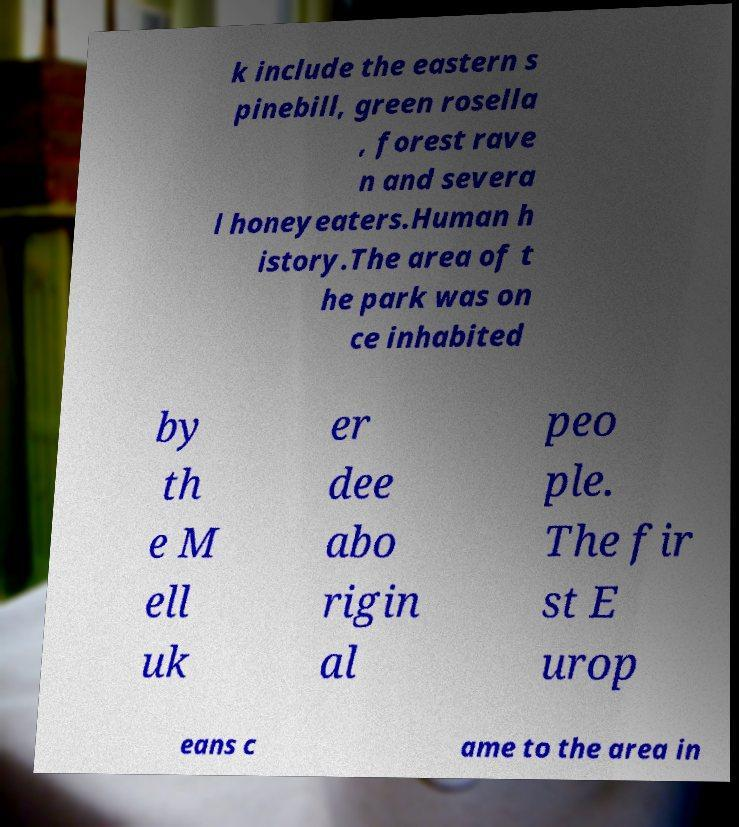There's text embedded in this image that I need extracted. Can you transcribe it verbatim? k include the eastern s pinebill, green rosella , forest rave n and severa l honeyeaters.Human h istory.The area of t he park was on ce inhabited by th e M ell uk er dee abo rigin al peo ple. The fir st E urop eans c ame to the area in 